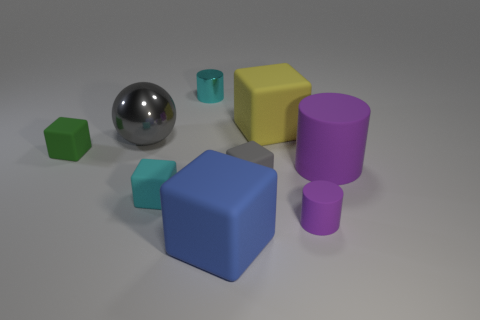There is a tiny rubber thing that is the same color as the large metal object; what shape is it?
Your answer should be very brief. Cube. Is there any other thing that has the same color as the large metal sphere?
Provide a short and direct response. Yes. Is the color of the small metallic object the same as the tiny matte block that is in front of the small gray rubber block?
Your answer should be compact. Yes. What shape is the small purple thing?
Provide a short and direct response. Cylinder. How many matte things are the same color as the ball?
Keep it short and to the point. 1. There is a metallic object that is the same shape as the small purple rubber thing; what is its color?
Offer a terse response. Cyan. How many large gray metallic spheres are to the left of the object that is in front of the tiny matte cylinder?
Make the answer very short. 1. What number of cubes are either cyan metallic things or big gray metal objects?
Your response must be concise. 0. Is there a big blue rubber cylinder?
Your answer should be compact. No. There is a green rubber object that is the same shape as the blue object; what size is it?
Make the answer very short. Small. 